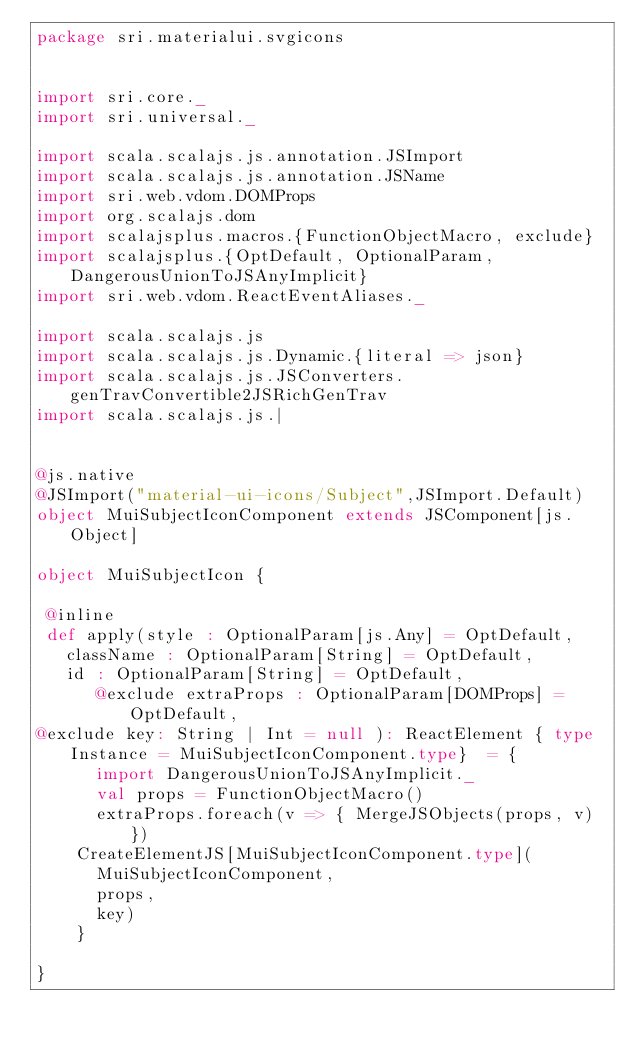<code> <loc_0><loc_0><loc_500><loc_500><_Scala_>package sri.materialui.svgicons


import sri.core._
import sri.universal._

import scala.scalajs.js.annotation.JSImport
import scala.scalajs.js.annotation.JSName
import sri.web.vdom.DOMProps
import org.scalajs.dom
import scalajsplus.macros.{FunctionObjectMacro, exclude}
import scalajsplus.{OptDefault, OptionalParam, DangerousUnionToJSAnyImplicit}
import sri.web.vdom.ReactEventAliases._

import scala.scalajs.js
import scala.scalajs.js.Dynamic.{literal => json}
import scala.scalajs.js.JSConverters.genTravConvertible2JSRichGenTrav
import scala.scalajs.js.|
     

@js.native
@JSImport("material-ui-icons/Subject",JSImport.Default)
object MuiSubjectIconComponent extends JSComponent[js.Object]

object MuiSubjectIcon {

 @inline
 def apply(style : OptionalParam[js.Any] = OptDefault,
   className : OptionalParam[String] = OptDefault,
   id : OptionalParam[String] = OptDefault,
      @exclude extraProps : OptionalParam[DOMProps] = OptDefault,
@exclude key: String | Int = null ): ReactElement { type Instance = MuiSubjectIconComponent.type}  = {
      import DangerousUnionToJSAnyImplicit._
      val props = FunctionObjectMacro()
      extraProps.foreach(v => { MergeJSObjects(props, v) })
    CreateElementJS[MuiSubjectIconComponent.type](
      MuiSubjectIconComponent,
      props,
      key)
    }

}

        
</code> 